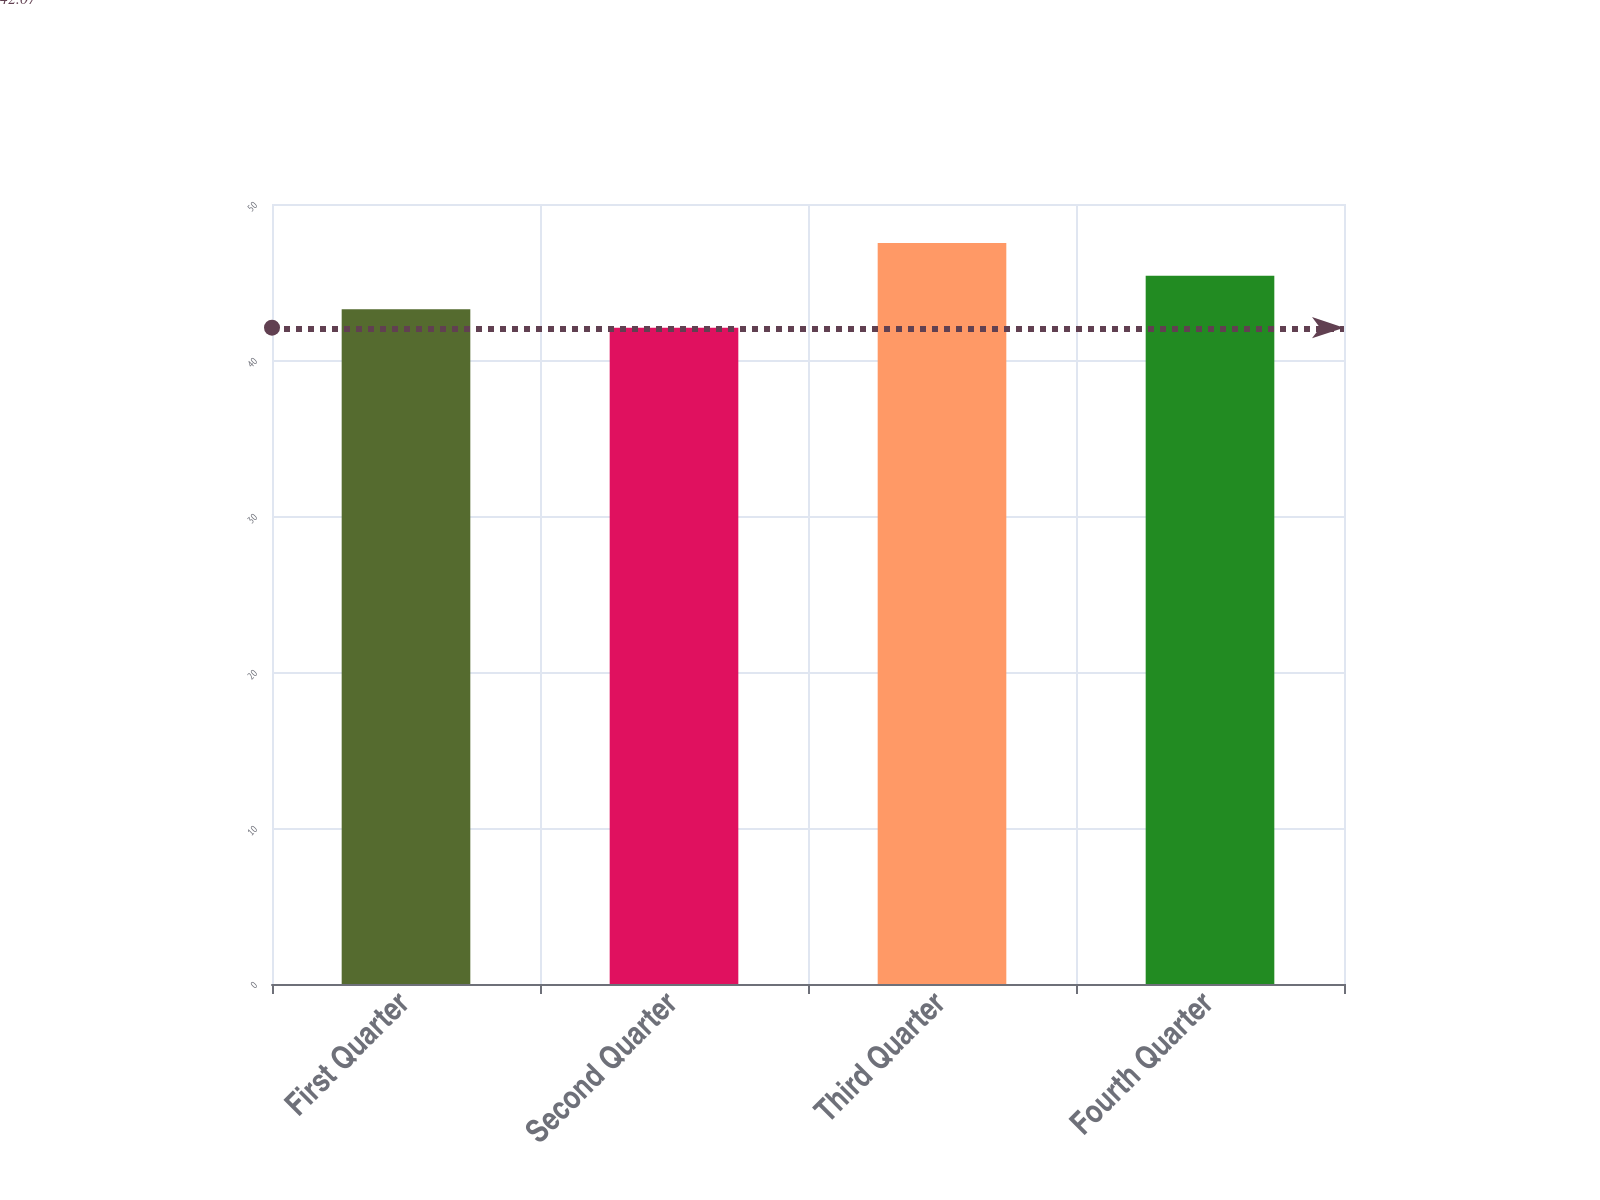Convert chart. <chart><loc_0><loc_0><loc_500><loc_500><bar_chart><fcel>First Quarter<fcel>Second Quarter<fcel>Third Quarter<fcel>Fourth Quarter<nl><fcel>43.25<fcel>42.07<fcel>47.5<fcel>45.4<nl></chart> 